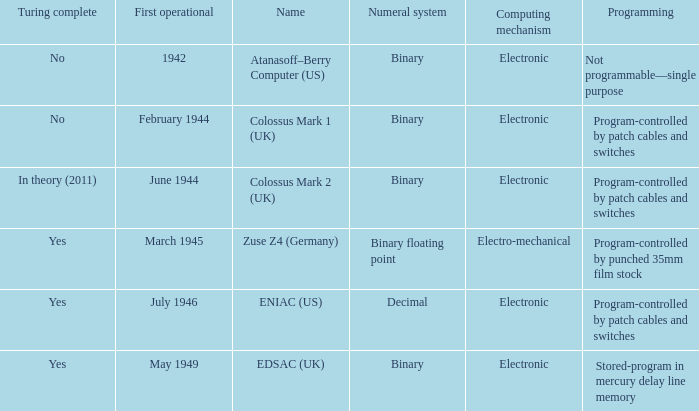What's the first operational with programming being not programmable—single purpose 1942.0. 